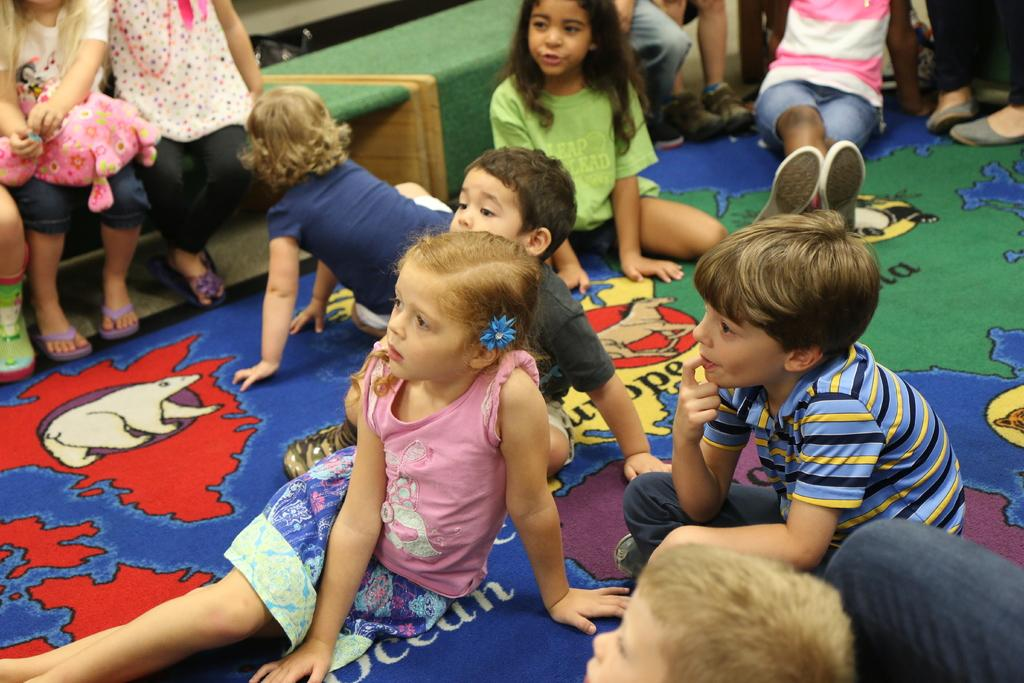Where are the children sitting in the image? There are children sitting on the carpet and on the bench. How many locations are the children sitting in? The children are sitting in two locations: the carpet and the bench. What type of news can be heard coming from the box in the image? There is no box present in the image, so it's not possible to determine what, if any, news might be heard. 